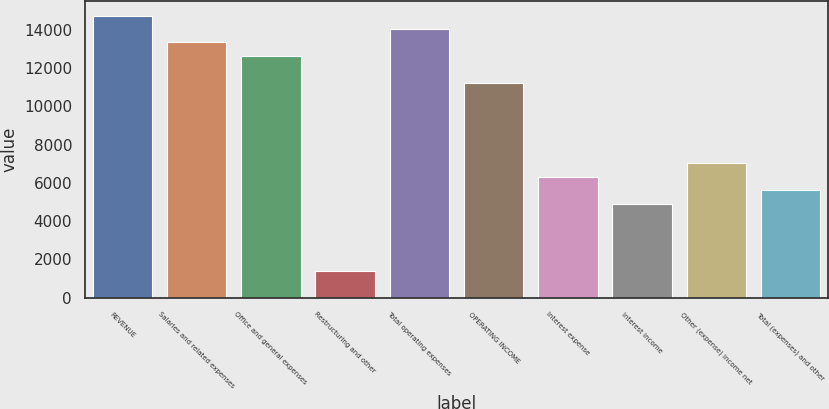Convert chart. <chart><loc_0><loc_0><loc_500><loc_500><bar_chart><fcel>REVENUE<fcel>Salaries and related expenses<fcel>Office and general expenses<fcel>Restructuring and other<fcel>Total operating expenses<fcel>OPERATING INCOME<fcel>Interest expense<fcel>Interest income<fcel>Other (expense) income net<fcel>Total (expenses) and other<nl><fcel>14730.5<fcel>13327.6<fcel>12626.2<fcel>1403.12<fcel>14029<fcel>11223.3<fcel>6313.2<fcel>4910.32<fcel>7014.64<fcel>5611.76<nl></chart> 